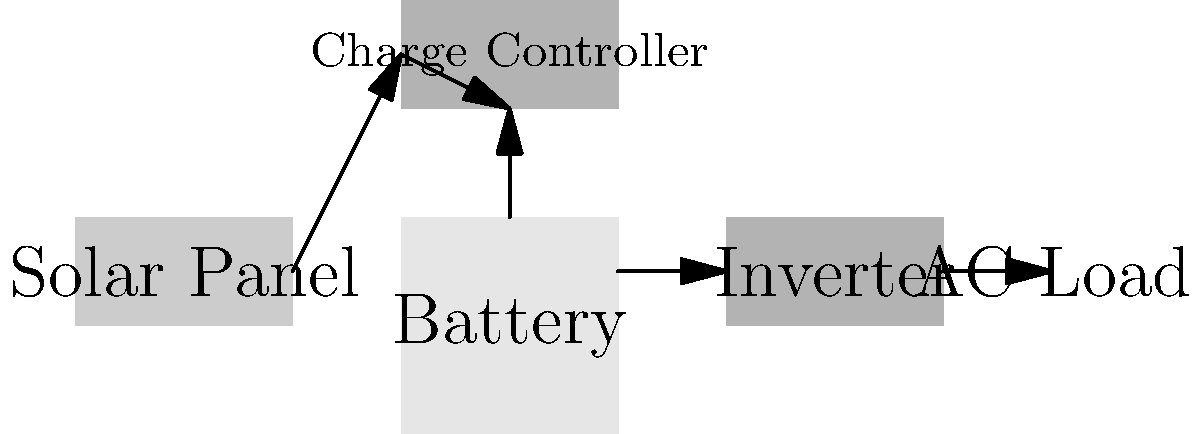In the wiring diagram for a solar power system in a remote clinic, what component is essential for converting the DC power from the solar panels and battery to AC power for medical equipment? Let's analyze the components of this solar power system step-by-step:

1. Solar Panel: Converts sunlight into DC (Direct Current) electricity.
2. Charge Controller: Regulates the voltage and current coming from the solar panels to safely charge the battery.
3. Battery: Stores the DC electricity for use when sunlight is not available.
4. Inverter: This is the key component for this question. It converts the DC power from the solar panels and battery into AC (Alternating Current) power.
5. AC Load: Represents the medical equipment in the clinic that requires AC power to operate.

The inverter is crucial because most medical equipment and standard electrical devices operate on AC power. Without the inverter, the DC power from the solar panels and battery couldn't be used to run these devices.

In the diagram, we can see that the inverter is placed between the battery and the AC load, indicating its role in converting DC to AC power before it reaches the medical equipment.
Answer: Inverter 